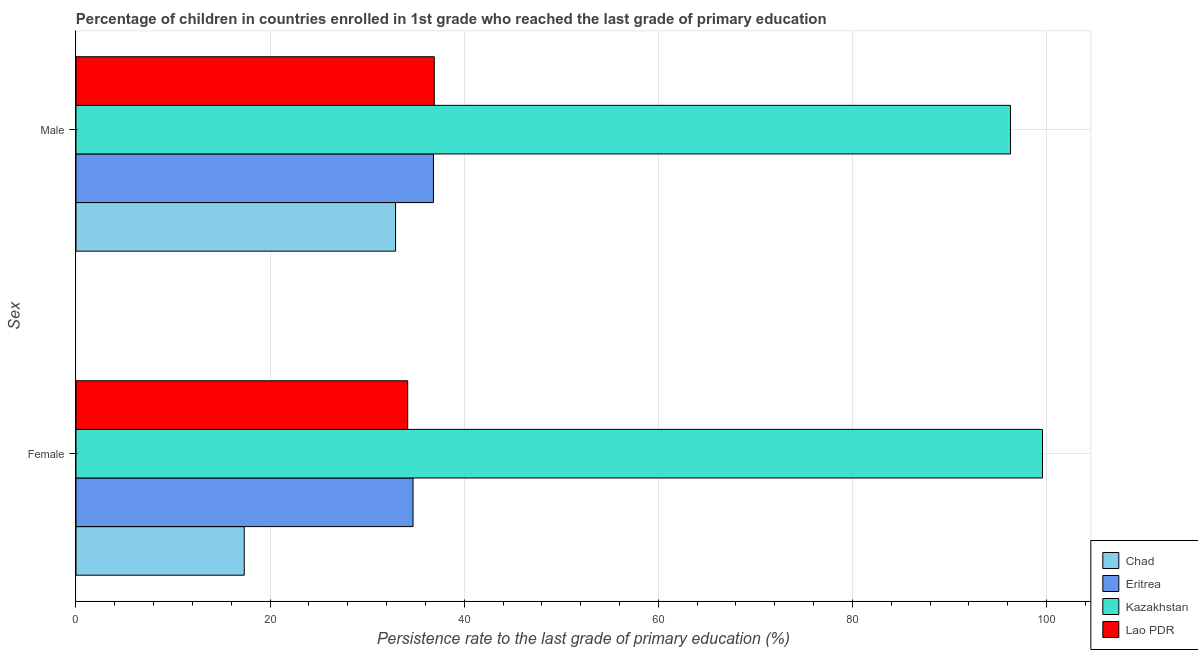Are the number of bars per tick equal to the number of legend labels?
Your response must be concise. Yes. How many bars are there on the 1st tick from the bottom?
Keep it short and to the point. 4. What is the label of the 2nd group of bars from the top?
Your answer should be compact. Female. What is the persistence rate of male students in Kazakhstan?
Your response must be concise. 96.29. Across all countries, what is the maximum persistence rate of male students?
Provide a succinct answer. 96.29. Across all countries, what is the minimum persistence rate of male students?
Ensure brevity in your answer.  32.93. In which country was the persistence rate of female students maximum?
Provide a short and direct response. Kazakhstan. In which country was the persistence rate of female students minimum?
Ensure brevity in your answer.  Chad. What is the total persistence rate of female students in the graph?
Your answer should be compact. 185.84. What is the difference between the persistence rate of female students in Chad and that in Kazakhstan?
Your answer should be very brief. -82.25. What is the difference between the persistence rate of male students in Lao PDR and the persistence rate of female students in Chad?
Provide a short and direct response. 19.58. What is the average persistence rate of female students per country?
Offer a terse response. 46.46. What is the difference between the persistence rate of male students and persistence rate of female students in Chad?
Offer a very short reply. 15.59. What is the ratio of the persistence rate of male students in Lao PDR to that in Chad?
Make the answer very short. 1.12. What does the 2nd bar from the top in Female represents?
Provide a succinct answer. Kazakhstan. What does the 4th bar from the bottom in Male represents?
Offer a very short reply. Lao PDR. Are all the bars in the graph horizontal?
Give a very brief answer. Yes. What is the difference between two consecutive major ticks on the X-axis?
Provide a short and direct response. 20. Are the values on the major ticks of X-axis written in scientific E-notation?
Give a very brief answer. No. How many legend labels are there?
Ensure brevity in your answer.  4. How are the legend labels stacked?
Keep it short and to the point. Vertical. What is the title of the graph?
Ensure brevity in your answer.  Percentage of children in countries enrolled in 1st grade who reached the last grade of primary education. Does "Pacific island small states" appear as one of the legend labels in the graph?
Provide a short and direct response. No. What is the label or title of the X-axis?
Your response must be concise. Persistence rate to the last grade of primary education (%). What is the label or title of the Y-axis?
Offer a terse response. Sex. What is the Persistence rate to the last grade of primary education (%) in Chad in Female?
Your answer should be very brief. 17.34. What is the Persistence rate to the last grade of primary education (%) in Eritrea in Female?
Offer a very short reply. 34.73. What is the Persistence rate to the last grade of primary education (%) in Kazakhstan in Female?
Your answer should be very brief. 99.59. What is the Persistence rate to the last grade of primary education (%) in Lao PDR in Female?
Give a very brief answer. 34.18. What is the Persistence rate to the last grade of primary education (%) of Chad in Male?
Your response must be concise. 32.93. What is the Persistence rate to the last grade of primary education (%) of Eritrea in Male?
Offer a terse response. 36.84. What is the Persistence rate to the last grade of primary education (%) of Kazakhstan in Male?
Offer a very short reply. 96.29. What is the Persistence rate to the last grade of primary education (%) in Lao PDR in Male?
Keep it short and to the point. 36.92. Across all Sex, what is the maximum Persistence rate to the last grade of primary education (%) in Chad?
Your answer should be compact. 32.93. Across all Sex, what is the maximum Persistence rate to the last grade of primary education (%) of Eritrea?
Give a very brief answer. 36.84. Across all Sex, what is the maximum Persistence rate to the last grade of primary education (%) of Kazakhstan?
Provide a succinct answer. 99.59. Across all Sex, what is the maximum Persistence rate to the last grade of primary education (%) of Lao PDR?
Offer a very short reply. 36.92. Across all Sex, what is the minimum Persistence rate to the last grade of primary education (%) of Chad?
Give a very brief answer. 17.34. Across all Sex, what is the minimum Persistence rate to the last grade of primary education (%) in Eritrea?
Your answer should be compact. 34.73. Across all Sex, what is the minimum Persistence rate to the last grade of primary education (%) in Kazakhstan?
Your response must be concise. 96.29. Across all Sex, what is the minimum Persistence rate to the last grade of primary education (%) of Lao PDR?
Your answer should be compact. 34.18. What is the total Persistence rate to the last grade of primary education (%) of Chad in the graph?
Provide a short and direct response. 50.27. What is the total Persistence rate to the last grade of primary education (%) of Eritrea in the graph?
Provide a succinct answer. 71.57. What is the total Persistence rate to the last grade of primary education (%) in Kazakhstan in the graph?
Give a very brief answer. 195.88. What is the total Persistence rate to the last grade of primary education (%) of Lao PDR in the graph?
Your answer should be very brief. 71.1. What is the difference between the Persistence rate to the last grade of primary education (%) of Chad in Female and that in Male?
Give a very brief answer. -15.59. What is the difference between the Persistence rate to the last grade of primary education (%) in Eritrea in Female and that in Male?
Your answer should be compact. -2.1. What is the difference between the Persistence rate to the last grade of primary education (%) of Kazakhstan in Female and that in Male?
Offer a very short reply. 3.3. What is the difference between the Persistence rate to the last grade of primary education (%) in Lao PDR in Female and that in Male?
Your answer should be very brief. -2.74. What is the difference between the Persistence rate to the last grade of primary education (%) of Chad in Female and the Persistence rate to the last grade of primary education (%) of Eritrea in Male?
Offer a terse response. -19.5. What is the difference between the Persistence rate to the last grade of primary education (%) of Chad in Female and the Persistence rate to the last grade of primary education (%) of Kazakhstan in Male?
Your answer should be compact. -78.95. What is the difference between the Persistence rate to the last grade of primary education (%) of Chad in Female and the Persistence rate to the last grade of primary education (%) of Lao PDR in Male?
Make the answer very short. -19.58. What is the difference between the Persistence rate to the last grade of primary education (%) of Eritrea in Female and the Persistence rate to the last grade of primary education (%) of Kazakhstan in Male?
Your answer should be compact. -61.56. What is the difference between the Persistence rate to the last grade of primary education (%) of Eritrea in Female and the Persistence rate to the last grade of primary education (%) of Lao PDR in Male?
Provide a short and direct response. -2.19. What is the difference between the Persistence rate to the last grade of primary education (%) in Kazakhstan in Female and the Persistence rate to the last grade of primary education (%) in Lao PDR in Male?
Give a very brief answer. 62.67. What is the average Persistence rate to the last grade of primary education (%) of Chad per Sex?
Ensure brevity in your answer.  25.13. What is the average Persistence rate to the last grade of primary education (%) in Eritrea per Sex?
Your response must be concise. 35.78. What is the average Persistence rate to the last grade of primary education (%) in Kazakhstan per Sex?
Make the answer very short. 97.94. What is the average Persistence rate to the last grade of primary education (%) in Lao PDR per Sex?
Provide a short and direct response. 35.55. What is the difference between the Persistence rate to the last grade of primary education (%) in Chad and Persistence rate to the last grade of primary education (%) in Eritrea in Female?
Provide a short and direct response. -17.39. What is the difference between the Persistence rate to the last grade of primary education (%) in Chad and Persistence rate to the last grade of primary education (%) in Kazakhstan in Female?
Offer a very short reply. -82.25. What is the difference between the Persistence rate to the last grade of primary education (%) in Chad and Persistence rate to the last grade of primary education (%) in Lao PDR in Female?
Provide a short and direct response. -16.84. What is the difference between the Persistence rate to the last grade of primary education (%) in Eritrea and Persistence rate to the last grade of primary education (%) in Kazakhstan in Female?
Make the answer very short. -64.86. What is the difference between the Persistence rate to the last grade of primary education (%) of Eritrea and Persistence rate to the last grade of primary education (%) of Lao PDR in Female?
Offer a terse response. 0.55. What is the difference between the Persistence rate to the last grade of primary education (%) in Kazakhstan and Persistence rate to the last grade of primary education (%) in Lao PDR in Female?
Ensure brevity in your answer.  65.41. What is the difference between the Persistence rate to the last grade of primary education (%) of Chad and Persistence rate to the last grade of primary education (%) of Eritrea in Male?
Make the answer very short. -3.91. What is the difference between the Persistence rate to the last grade of primary education (%) of Chad and Persistence rate to the last grade of primary education (%) of Kazakhstan in Male?
Keep it short and to the point. -63.36. What is the difference between the Persistence rate to the last grade of primary education (%) of Chad and Persistence rate to the last grade of primary education (%) of Lao PDR in Male?
Ensure brevity in your answer.  -3.99. What is the difference between the Persistence rate to the last grade of primary education (%) of Eritrea and Persistence rate to the last grade of primary education (%) of Kazakhstan in Male?
Your response must be concise. -59.46. What is the difference between the Persistence rate to the last grade of primary education (%) in Eritrea and Persistence rate to the last grade of primary education (%) in Lao PDR in Male?
Your answer should be very brief. -0.08. What is the difference between the Persistence rate to the last grade of primary education (%) of Kazakhstan and Persistence rate to the last grade of primary education (%) of Lao PDR in Male?
Provide a succinct answer. 59.38. What is the ratio of the Persistence rate to the last grade of primary education (%) of Chad in Female to that in Male?
Provide a short and direct response. 0.53. What is the ratio of the Persistence rate to the last grade of primary education (%) in Eritrea in Female to that in Male?
Give a very brief answer. 0.94. What is the ratio of the Persistence rate to the last grade of primary education (%) in Kazakhstan in Female to that in Male?
Make the answer very short. 1.03. What is the ratio of the Persistence rate to the last grade of primary education (%) in Lao PDR in Female to that in Male?
Keep it short and to the point. 0.93. What is the difference between the highest and the second highest Persistence rate to the last grade of primary education (%) in Chad?
Ensure brevity in your answer.  15.59. What is the difference between the highest and the second highest Persistence rate to the last grade of primary education (%) of Eritrea?
Your answer should be compact. 2.1. What is the difference between the highest and the second highest Persistence rate to the last grade of primary education (%) in Kazakhstan?
Offer a terse response. 3.3. What is the difference between the highest and the second highest Persistence rate to the last grade of primary education (%) in Lao PDR?
Offer a very short reply. 2.74. What is the difference between the highest and the lowest Persistence rate to the last grade of primary education (%) in Chad?
Offer a very short reply. 15.59. What is the difference between the highest and the lowest Persistence rate to the last grade of primary education (%) in Eritrea?
Your response must be concise. 2.1. What is the difference between the highest and the lowest Persistence rate to the last grade of primary education (%) of Kazakhstan?
Offer a very short reply. 3.3. What is the difference between the highest and the lowest Persistence rate to the last grade of primary education (%) in Lao PDR?
Your answer should be very brief. 2.74. 